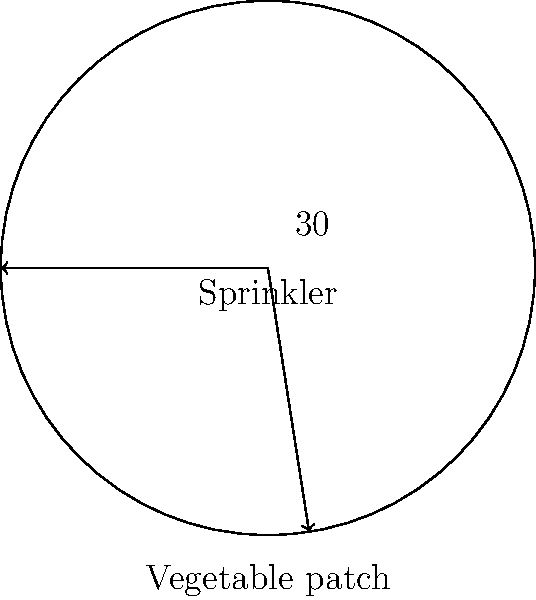As you plan the irrigation for your circular vegetable patch, you need to set up a rotating sprinkler at the center. If the sprinkler can cover a $60°$ arc in one rotation, what should be the angle between each consecutive position to ensure the entire patch is watered evenly? Let's approach this step-by-step:

1) First, recall that a full circle contains $360°$.

2) The sprinkler covers $60°$ in one position. We need to find how many such positions are needed to cover the entire circle.

3) To calculate this, we divide the total angle of the circle by the angle covered by the sprinkler in one position:

   $\text{Number of positions} = \frac{360°}{60°} = 6$

4) Now that we know we need 6 positions, we need to find the angle between each position.

5) Since the positions should be evenly spaced around the circle, we divide the total angle of the circle by the number of positions:

   $\text{Angle between positions} = \frac{360°}{6} = 60°$

6) Therefore, the sprinkler should be moved by $60°$ between each consecutive position to ensure even coverage of the entire vegetable patch.

This angle coincides with the coverage of the sprinkler, which means it will provide complete and even coverage with no overlaps or gaps.
Answer: $60°$ 